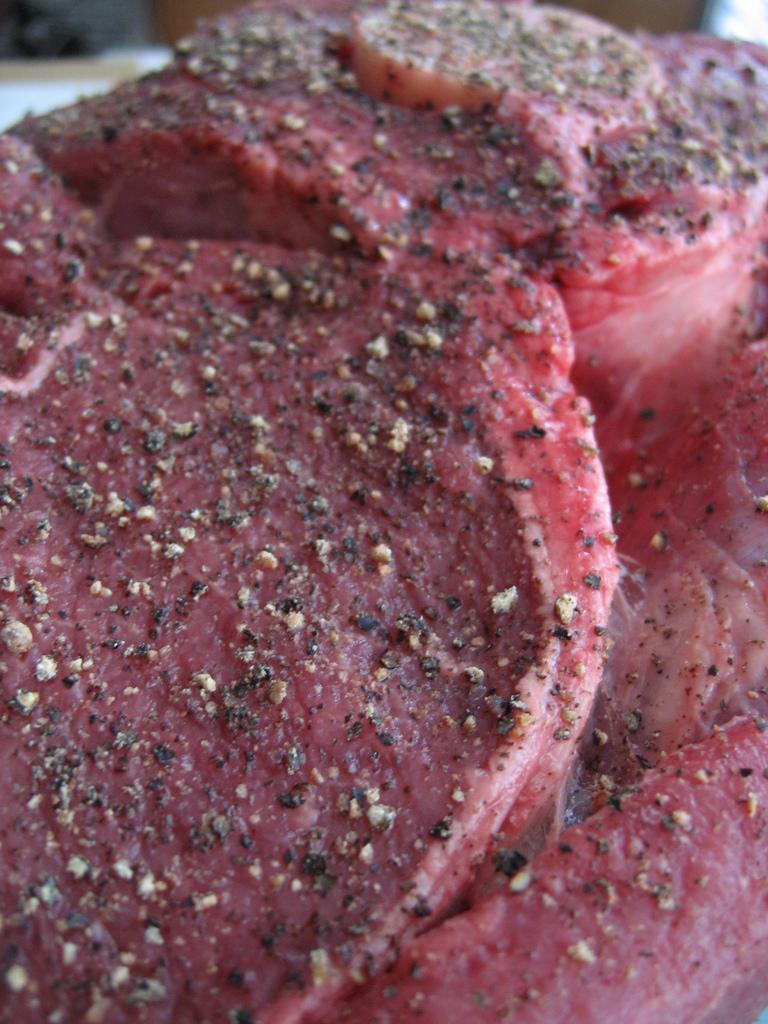Describe this image in one or two sentences. In the picture there is brisket in the center of the image, it seems to be some spices on it. 